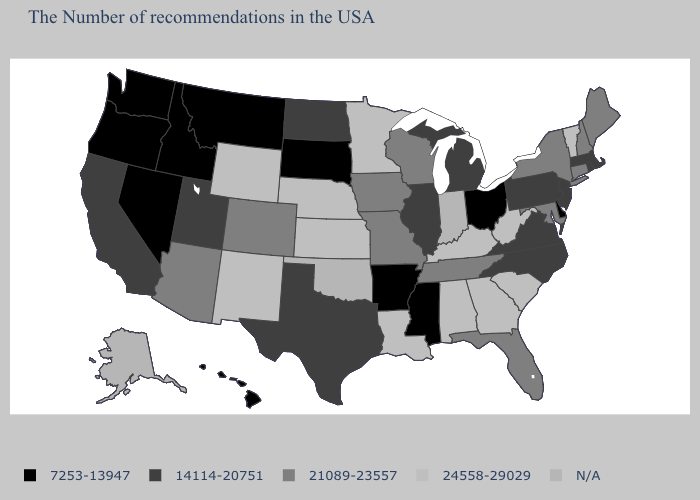What is the value of Wisconsin?
Be succinct. 21089-23557. Name the states that have a value in the range 24558-29029?
Write a very short answer. Vermont, South Carolina, West Virginia, Georgia, Kentucky, Alabama, Louisiana, Minnesota, Kansas, Nebraska, Wyoming, New Mexico. Among the states that border Pennsylvania , which have the lowest value?
Quick response, please. Delaware, Ohio. What is the value of South Carolina?
Short answer required. 24558-29029. What is the value of Wyoming?
Answer briefly. 24558-29029. Name the states that have a value in the range 24558-29029?
Answer briefly. Vermont, South Carolina, West Virginia, Georgia, Kentucky, Alabama, Louisiana, Minnesota, Kansas, Nebraska, Wyoming, New Mexico. What is the value of Texas?
Be succinct. 14114-20751. Name the states that have a value in the range 14114-20751?
Keep it brief. Massachusetts, Rhode Island, New Jersey, Pennsylvania, Virginia, North Carolina, Michigan, Illinois, Texas, North Dakota, Utah, California. What is the value of Kansas?
Write a very short answer. 24558-29029. Name the states that have a value in the range 7253-13947?
Quick response, please. Delaware, Ohio, Mississippi, Arkansas, South Dakota, Montana, Idaho, Nevada, Washington, Oregon, Hawaii. What is the highest value in the South ?
Give a very brief answer. 24558-29029. Name the states that have a value in the range 7253-13947?
Answer briefly. Delaware, Ohio, Mississippi, Arkansas, South Dakota, Montana, Idaho, Nevada, Washington, Oregon, Hawaii. Is the legend a continuous bar?
Keep it brief. No. Name the states that have a value in the range 24558-29029?
Short answer required. Vermont, South Carolina, West Virginia, Georgia, Kentucky, Alabama, Louisiana, Minnesota, Kansas, Nebraska, Wyoming, New Mexico. What is the value of Minnesota?
Answer briefly. 24558-29029. 